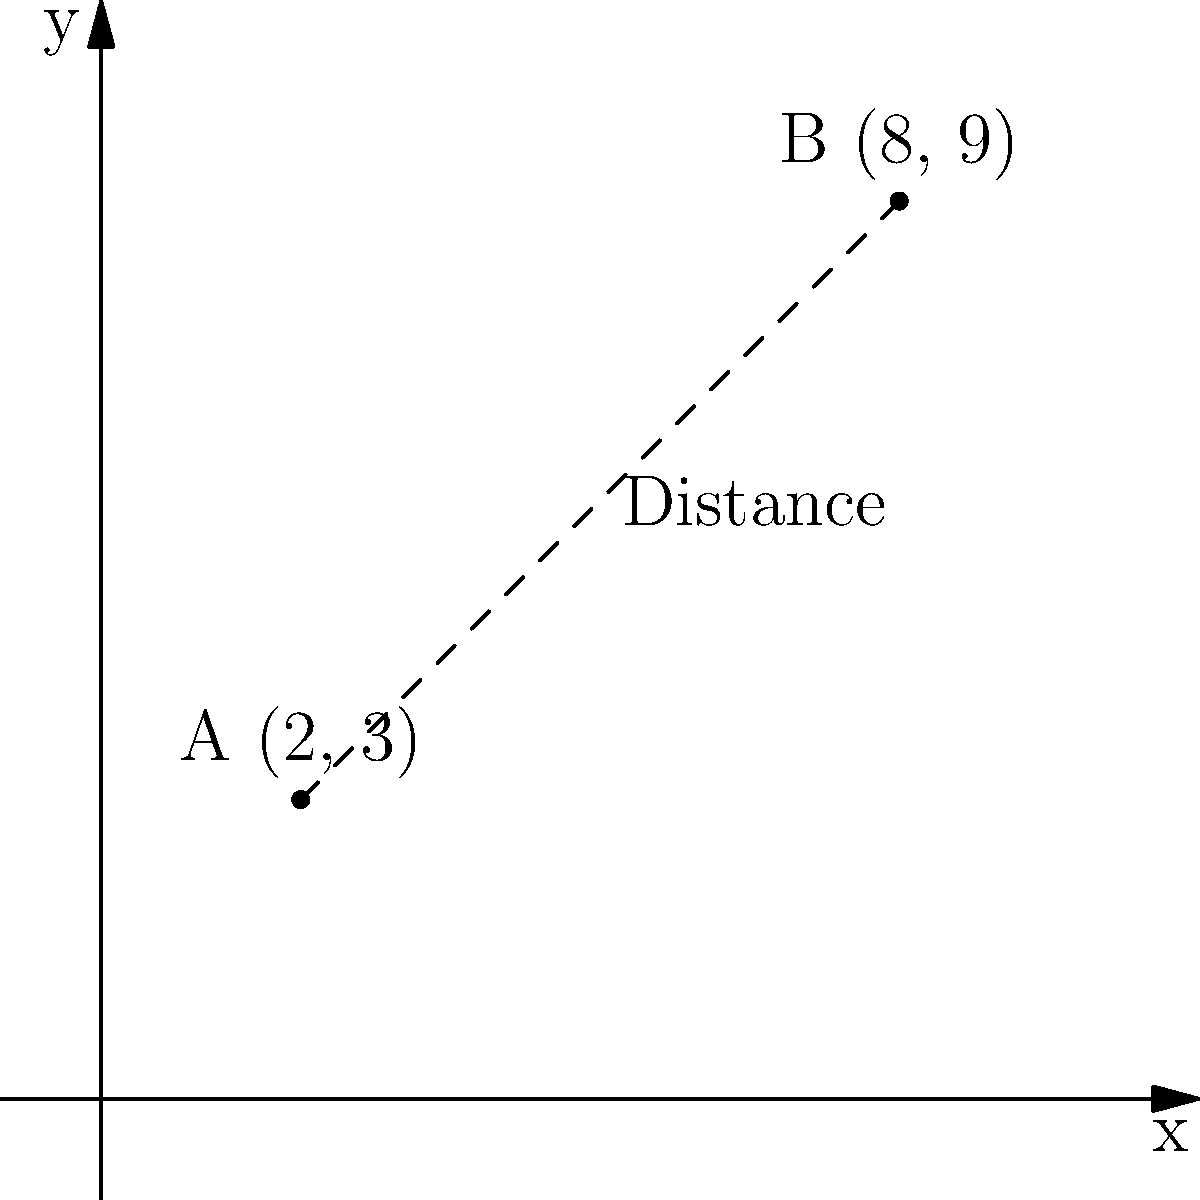As a sports journalist covering women's basketball in Puerto Rico, you're tasked with calculating the distance between two newly built basketball courts in San Juan. On the city map, Court A is located at coordinates (2, 3) and Court B is at (8, 9), where each unit represents 1 kilometer. Using the distance formula, calculate the straight-line distance between these two courts. To solve this problem, we'll use the distance formula, which is derived from the Pythagorean theorem:

$$d = \sqrt{(x_2 - x_1)^2 + (y_2 - y_1)^2}$$

Where $(x_1, y_1)$ are the coordinates of the first point and $(x_2, y_2)$ are the coordinates of the second point.

Given:
- Court A: $(x_1, y_1) = (2, 3)$
- Court B: $(x_2, y_2) = (8, 9)$

Let's plug these values into the formula:

$$d = \sqrt{(8 - 2)^2 + (9 - 3)^2}$$

Simplify inside the parentheses:
$$d = \sqrt{6^2 + 6^2}$$

Calculate the squares:
$$d = \sqrt{36 + 36}$$

Add under the square root:
$$d = \sqrt{72}$$

Simplify the square root:
$$d = 6\sqrt{2}$$

Since each unit represents 1 kilometer, the distance between the two courts is $6\sqrt{2}$ kilometers.
Answer: $6\sqrt{2}$ km 